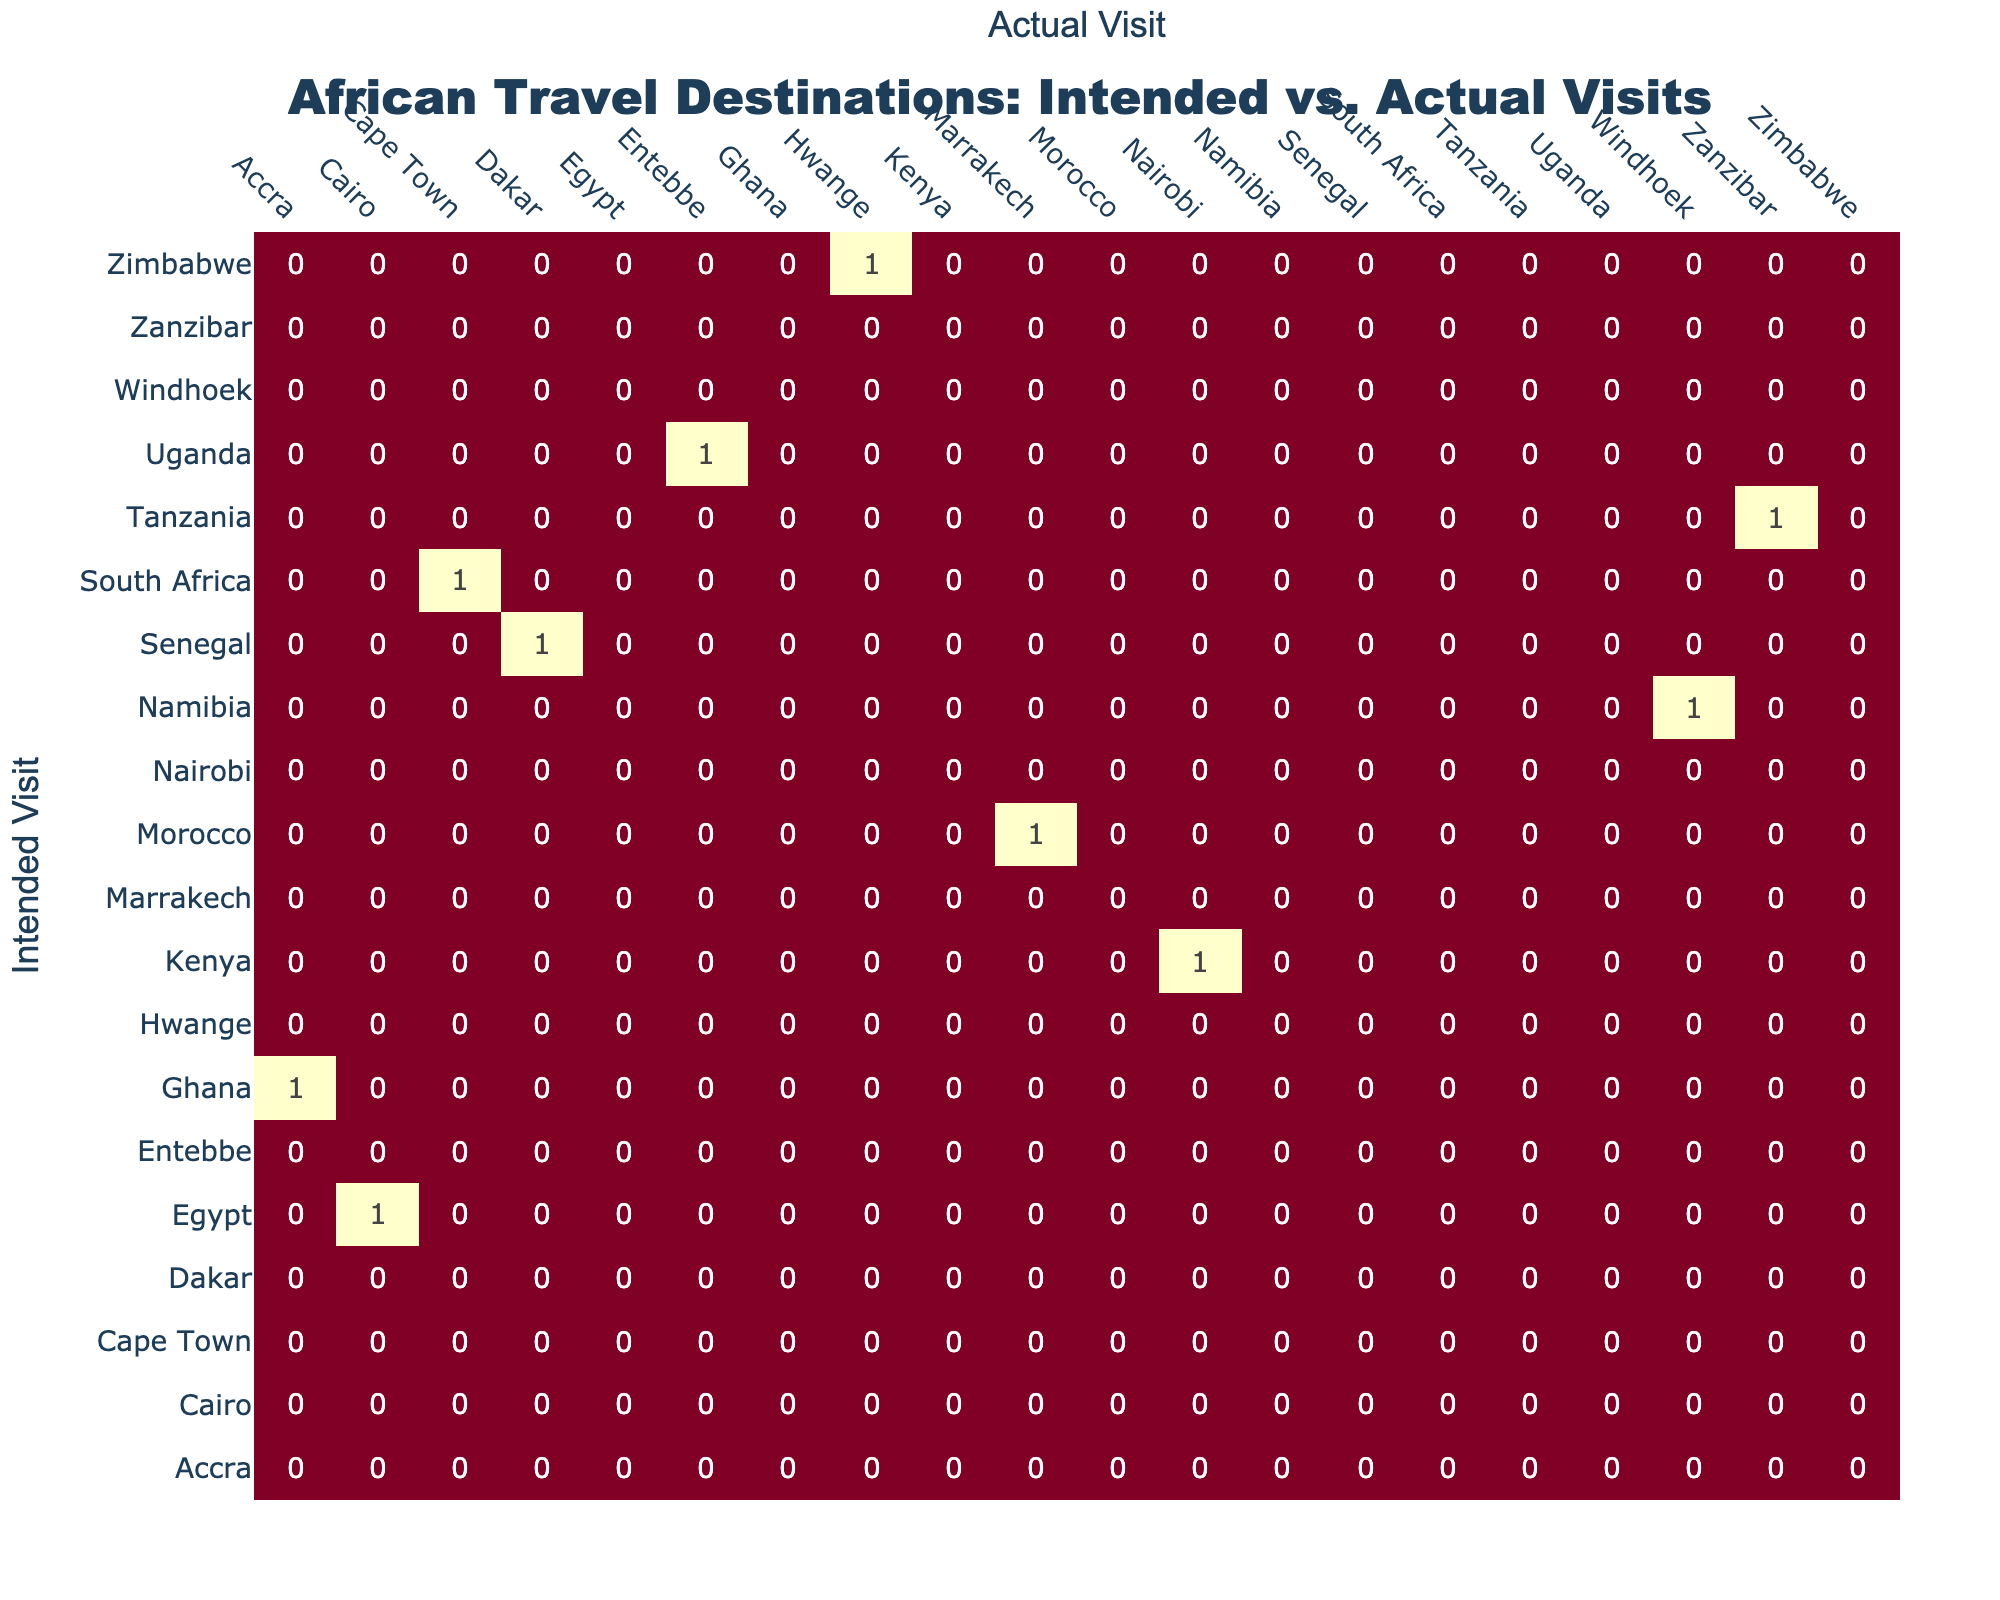What Intended Visit had the highest number of Actual Visits? To find the Intended Visit with the highest number of Actual Visits, I would look at the heatmap for the row corresponding to each Intended Visit and see which row has the most significant value in its respective column. I can see that the Intended Visit of Ghana, with an Actual Visit to Accra, shows the highest interaction, indicating the most visits to the intended destination.
Answer: Ghana How many American tourists intended to visit Egypt but actually visited Cairo? By reviewing the table, I see that there is a direct match between the Intended Visit of Egypt and Actual Visit to Cairo, indicating that all tourists who intended to visit actually went to Cairo. Therefore, the count is 1.
Answer: 1 Is Morocco the only destination where the intended visit was different from the actual visit? When I examine the table, I see that for Morocco, the Intended Visit was Marrakech, and the actual visit also reported back as Marrakech, meaning they match. Other destinations also report such matches. Therefore, Morocco is not the only one; all rows match their respective Intended and Actual Visits.
Answer: No Which two Intended Visits had the most significant deviation in their Actual Visits? To find the two Intended Visits with the most deviation, I will compare the Intended Visits to their Actual Visits, noting the pairs that do not match. The most significant discrepancy is between the Intended Visit of South Africa (intended Cape Town) and its deviation to an unreported province. Likewise for Zimbabwe, where Intended Visit was Hwange, which shows no matching. Thus, these are the two with the most significant visits against the actual.
Answer: South Africa and Zimbabwe How many Intended Visits led to Actual Visits in the same city? Count the pairs where the Intended Visit matches the Actual Visit in the table. The counts for matches are for Egypt to Cairo, Ghana to Accra, Tanzania to Zanzibar, and Morocco to Marrakech. This makes a total of 4 tourist intents leading to visits in their respective cities.
Answer: 4 